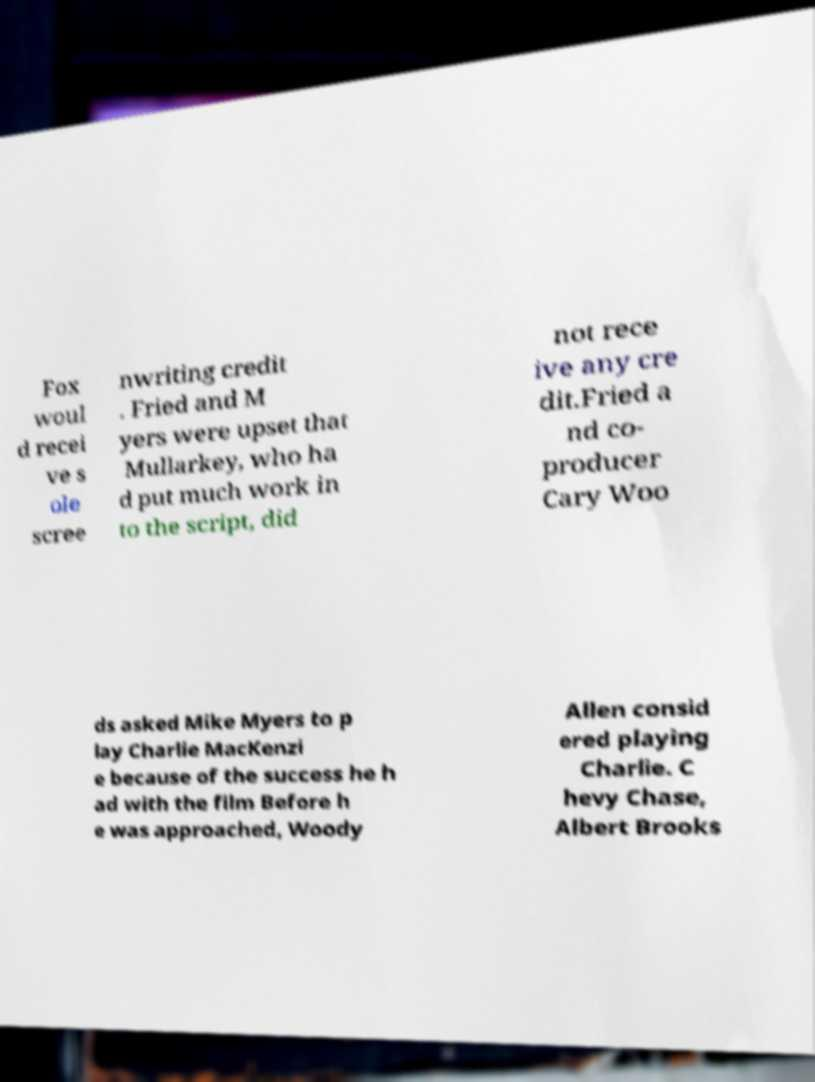What messages or text are displayed in this image? I need them in a readable, typed format. Fox woul d recei ve s ole scree nwriting credit . Fried and M yers were upset that Mullarkey, who ha d put much work in to the script, did not rece ive any cre dit.Fried a nd co- producer Cary Woo ds asked Mike Myers to p lay Charlie MacKenzi e because of the success he h ad with the film Before h e was approached, Woody Allen consid ered playing Charlie. C hevy Chase, Albert Brooks 